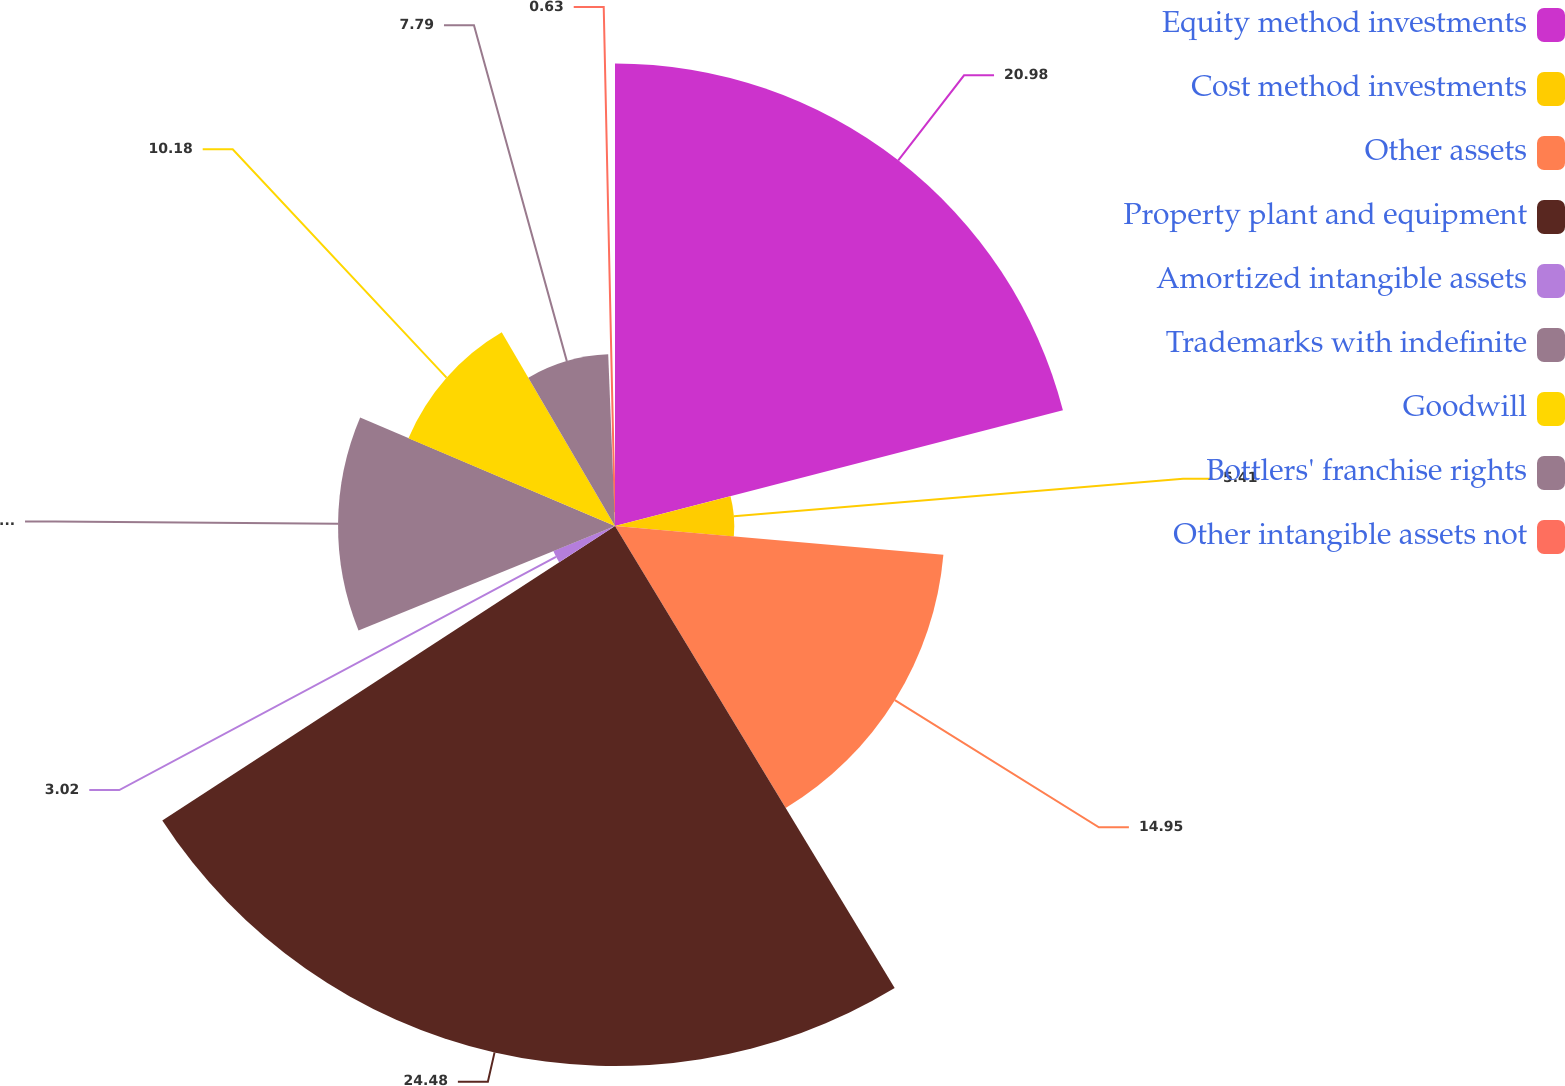<chart> <loc_0><loc_0><loc_500><loc_500><pie_chart><fcel>Equity method investments<fcel>Cost method investments<fcel>Other assets<fcel>Property plant and equipment<fcel>Amortized intangible assets<fcel>Trademarks with indefinite<fcel>Goodwill<fcel>Bottlers' franchise rights<fcel>Other intangible assets not<nl><fcel>20.98%<fcel>5.41%<fcel>14.95%<fcel>24.49%<fcel>3.02%<fcel>12.56%<fcel>10.18%<fcel>7.79%<fcel>0.63%<nl></chart> 